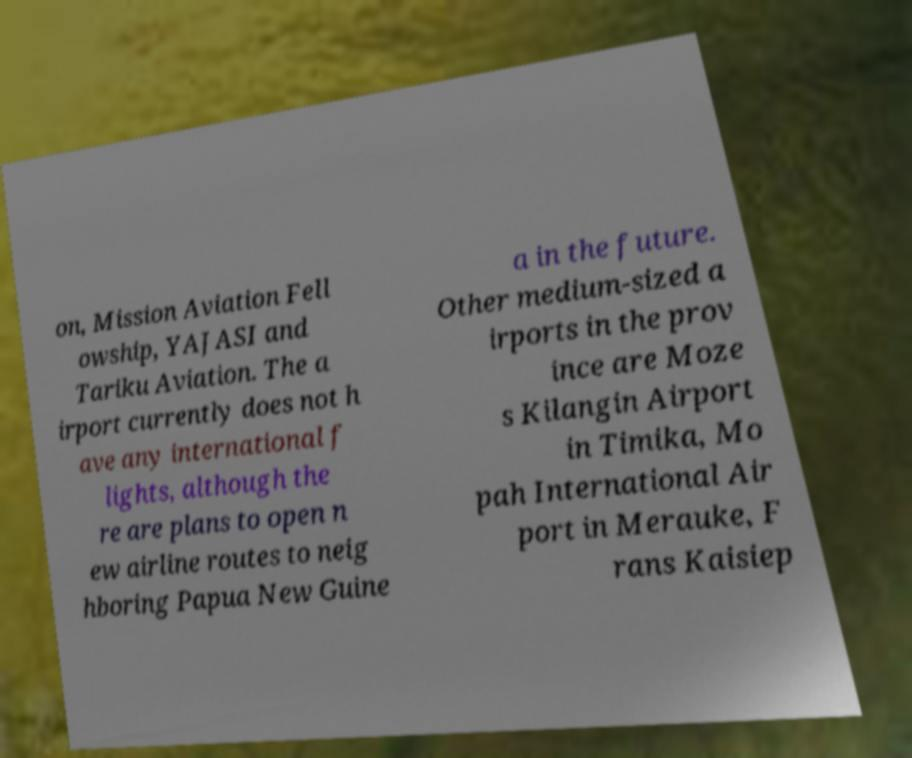For documentation purposes, I need the text within this image transcribed. Could you provide that? on, Mission Aviation Fell owship, YAJASI and Tariku Aviation. The a irport currently does not h ave any international f lights, although the re are plans to open n ew airline routes to neig hboring Papua New Guine a in the future. Other medium-sized a irports in the prov ince are Moze s Kilangin Airport in Timika, Mo pah International Air port in Merauke, F rans Kaisiep 